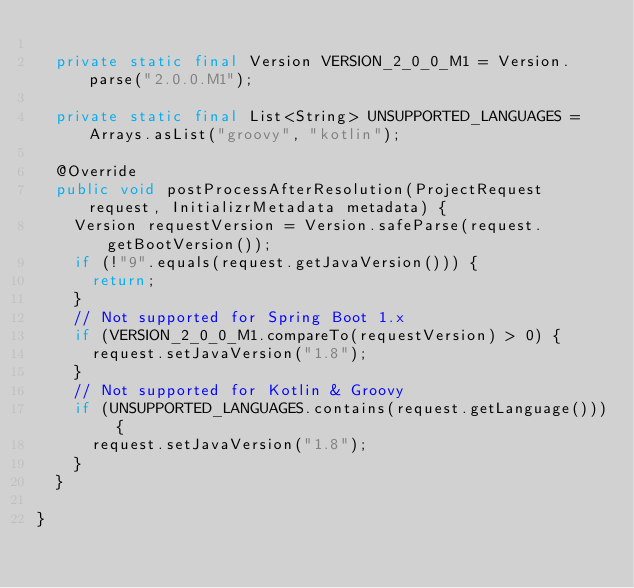Convert code to text. <code><loc_0><loc_0><loc_500><loc_500><_Java_>
	private static final Version VERSION_2_0_0_M1 = Version.parse("2.0.0.M1");

	private static final List<String> UNSUPPORTED_LANGUAGES = Arrays.asList("groovy", "kotlin");

	@Override
	public void postProcessAfterResolution(ProjectRequest request, InitializrMetadata metadata) {
		Version requestVersion = Version.safeParse(request.getBootVersion());
		if (!"9".equals(request.getJavaVersion())) {
			return;
		}
		// Not supported for Spring Boot 1.x
		if (VERSION_2_0_0_M1.compareTo(requestVersion) > 0) {
			request.setJavaVersion("1.8");
		}
		// Not supported for Kotlin & Groovy
		if (UNSUPPORTED_LANGUAGES.contains(request.getLanguage())) {
			request.setJavaVersion("1.8");
		}
	}

}
</code> 